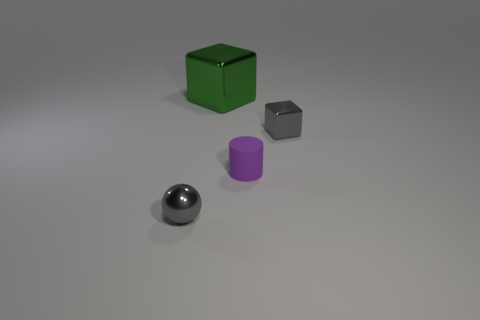Is there anything else that has the same material as the cylinder?
Offer a very short reply. No. Is there a metallic object?
Your answer should be compact. Yes. What number of objects are metallic objects that are left of the big block or tiny metallic balls?
Your answer should be very brief. 1. Is the color of the matte cylinder the same as the tiny shiny thing in front of the purple matte thing?
Provide a short and direct response. No. Are there any purple things that have the same size as the green metallic block?
Provide a succinct answer. No. What material is the small gray thing that is behind the metal object in front of the gray block?
Ensure brevity in your answer.  Metal. What number of tiny metal spheres have the same color as the large thing?
Your answer should be compact. 0. What shape is the tiny gray thing that is made of the same material as the ball?
Your answer should be very brief. Cube. There is a gray shiny object behind the small purple rubber object; what size is it?
Make the answer very short. Small. Are there the same number of green metallic things that are behind the tiny purple cylinder and gray objects in front of the tiny ball?
Your answer should be very brief. No. 